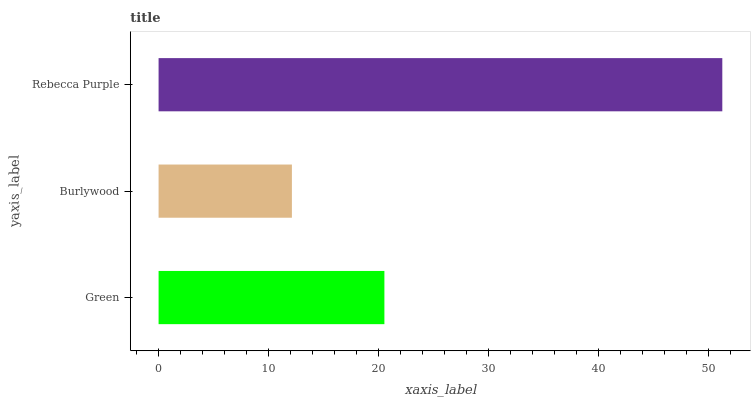Is Burlywood the minimum?
Answer yes or no. Yes. Is Rebecca Purple the maximum?
Answer yes or no. Yes. Is Rebecca Purple the minimum?
Answer yes or no. No. Is Burlywood the maximum?
Answer yes or no. No. Is Rebecca Purple greater than Burlywood?
Answer yes or no. Yes. Is Burlywood less than Rebecca Purple?
Answer yes or no. Yes. Is Burlywood greater than Rebecca Purple?
Answer yes or no. No. Is Rebecca Purple less than Burlywood?
Answer yes or no. No. Is Green the high median?
Answer yes or no. Yes. Is Green the low median?
Answer yes or no. Yes. Is Burlywood the high median?
Answer yes or no. No. Is Rebecca Purple the low median?
Answer yes or no. No. 